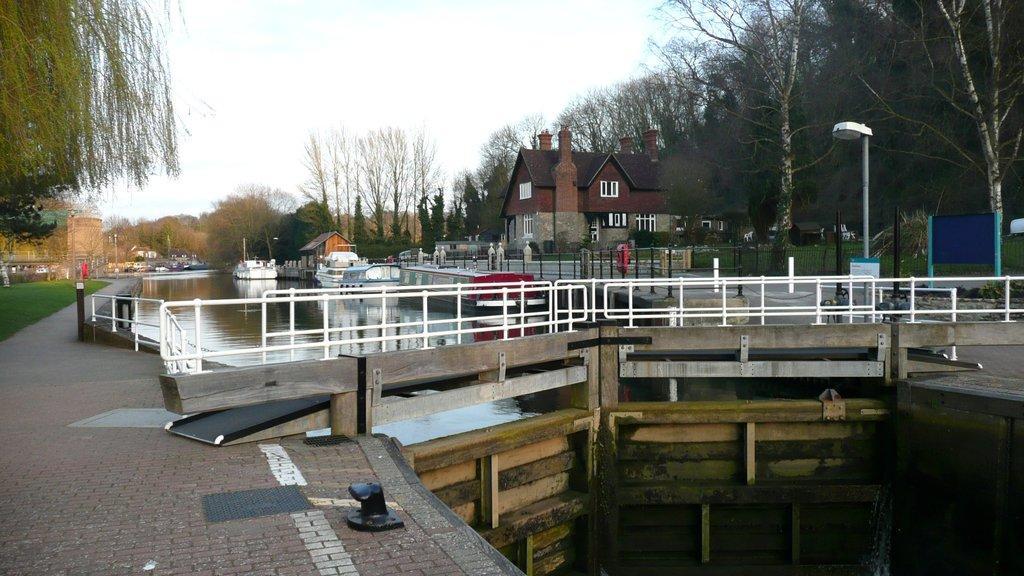Could you give a brief overview of what you see in this image? This image consists of a bridge made up of wood. In the middle, there is water on which there are boats. To the left, there is a road. To the right, there is house along with the trees. At the top, there is a sky. 